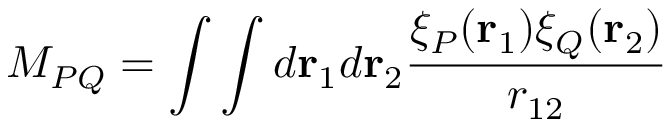<formula> <loc_0><loc_0><loc_500><loc_500>M _ { P Q } = \int \int d r _ { 1 } d r _ { 2 } \frac { \xi _ { P } ( r _ { 1 } ) \xi _ { Q } ( r _ { 2 } ) } { r _ { 1 2 } }</formula> 